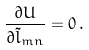Convert formula to latex. <formula><loc_0><loc_0><loc_500><loc_500>\frac { \partial U } { \partial \tilde { l } _ { m n } } = 0 \, .</formula> 